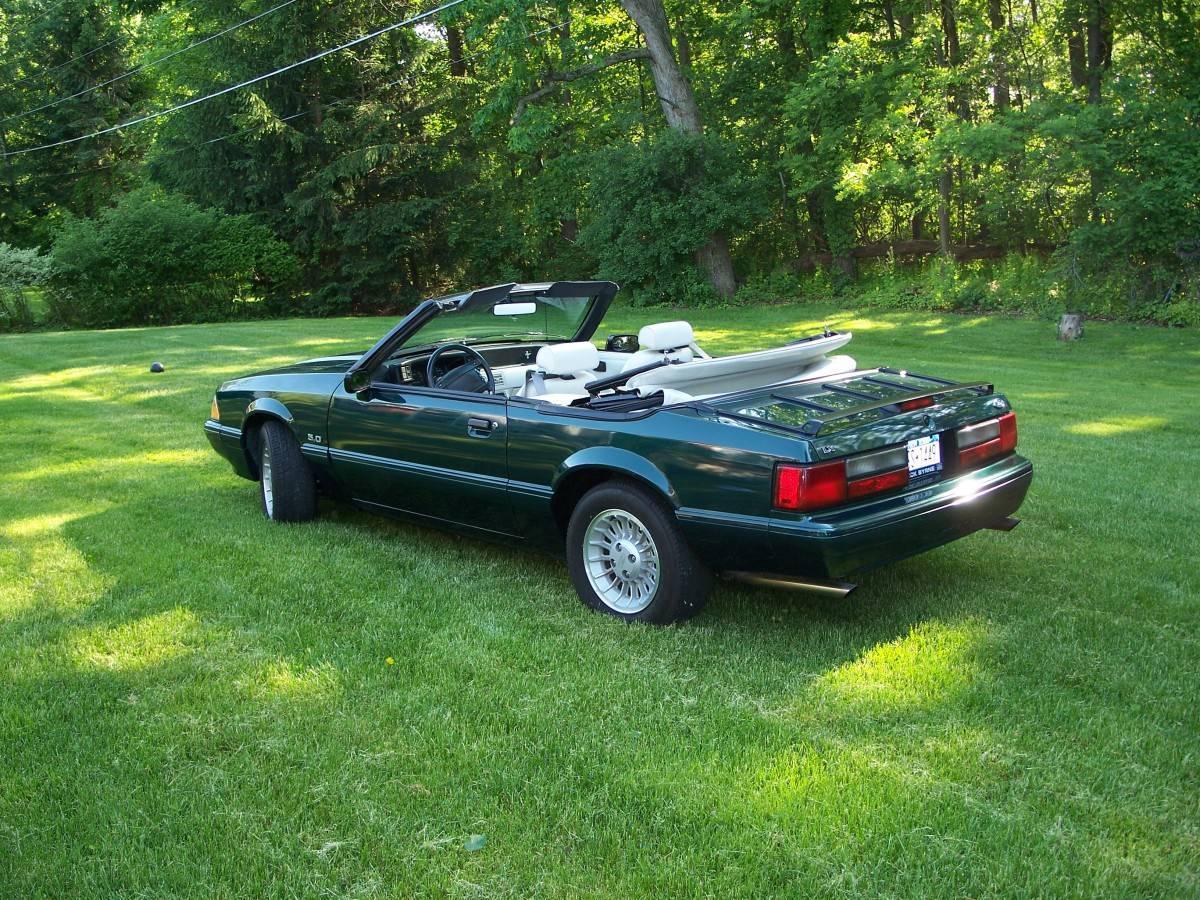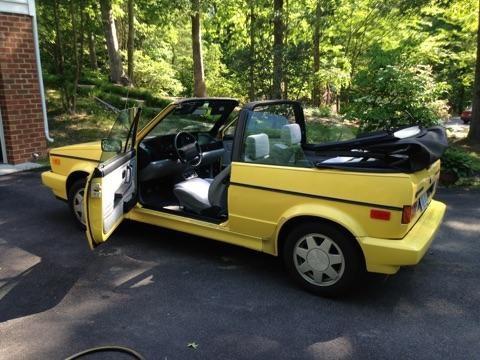The first image is the image on the left, the second image is the image on the right. For the images displayed, is the sentence "An image shows a yellow car parked and facing leftward." factually correct? Answer yes or no. Yes. The first image is the image on the left, the second image is the image on the right. For the images shown, is this caption "The car on the right has its top down." true? Answer yes or no. Yes. 